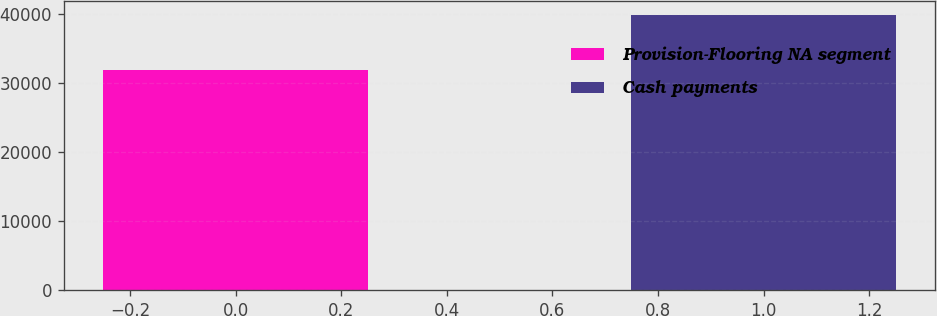Convert chart. <chart><loc_0><loc_0><loc_500><loc_500><bar_chart><fcel>Provision-Flooring NA segment<fcel>Cash payments<nl><fcel>31796<fcel>39833<nl></chart> 